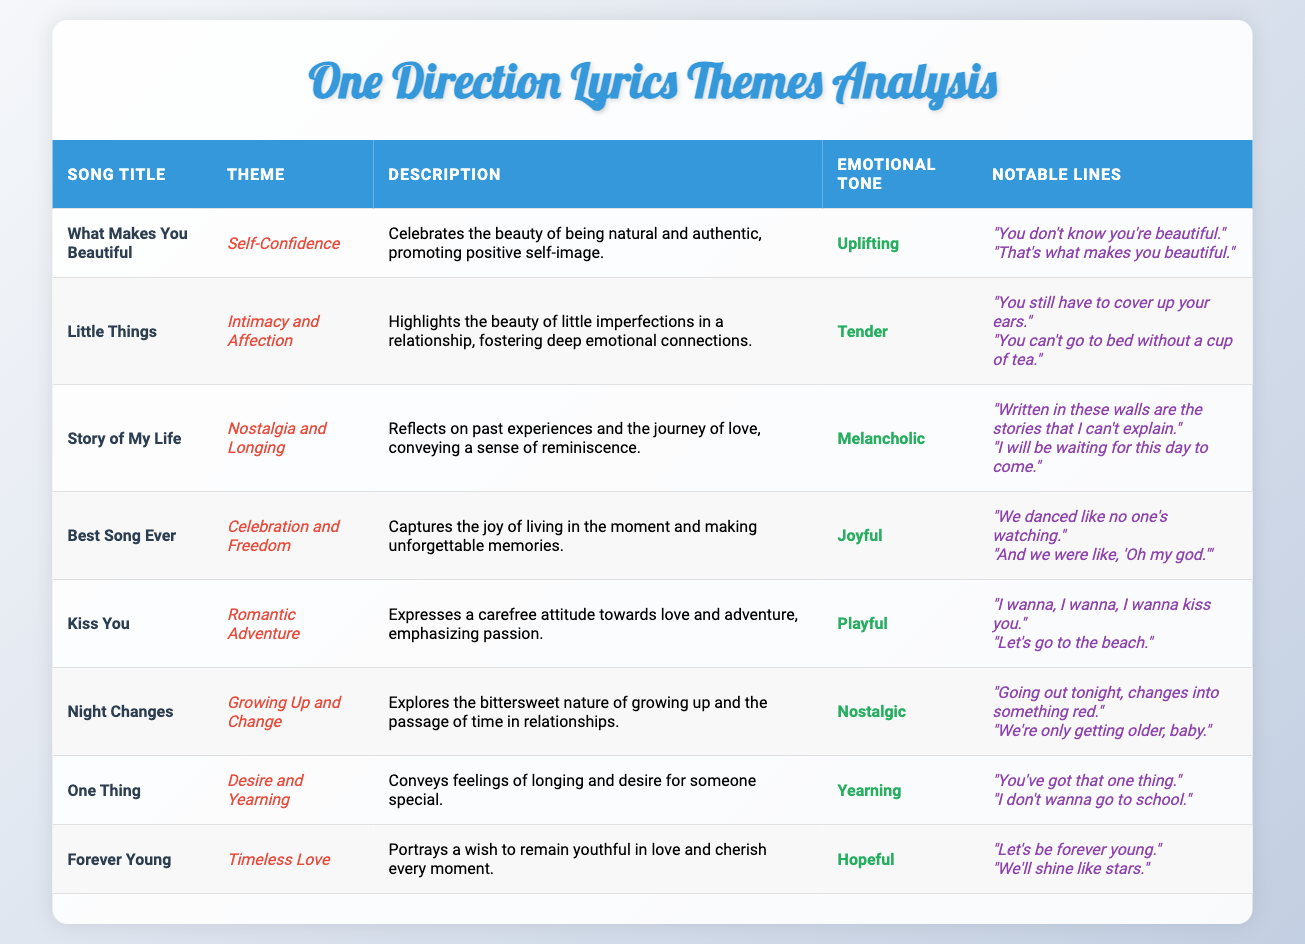What theme is associated with the song "Kiss You"? The song "Kiss You" has the theme of "Romantic Adventure." This is directly stated in the table under the "Theme" column for the respective song title.
Answer: Romantic Adventure Which song has a melancholic emotional tone? "Story of My Life" is listed in the table with a melancholic emotional tone in the corresponding column.
Answer: Story of My Life Are there any songs that focus on self-confidence? Yes, "What Makes You Beautiful" is clearly labeled in the theme column as focusing on self-confidence.
Answer: Yes What are the notable lines from the song "Night Changes"? The notable lines for "Night Changes," as shown in the table, are "Going out tonight, changes into something red." and "We're only getting older, baby." These lines can be found in the notable lines column for that specific song.
Answer: "Going out tonight, changes into something red." and "We're only getting older, baby." What is the average emotional tone of the songs listed? The emotional tones of the songs are categorized as follows: Uplifting, Tender, Melancholic, Joyful, Playful, Nostalgic, Yearning, and Hopeful. Since there are no numerical values assigned to these tones, an average cannot be calculated directly. Thus, the answer is that an average emotional tone cannot be determined from this qualitative data.
Answer: Average emotional tone cannot be calculated Which two songs have themes related to nostalgia? The two songs linked to the theme of nostalgia are "Story of My Life" and "Night Changes." By reviewing the table, both songs are categorized under nostalgia-related themes in their respective rows.
Answer: Story of My Life and Night Changes What is the relationship between the themes of "Little Things" and "One Thing"? "Little Things" has a theme of intimacy and affection, while "One Thing" relates to desire and yearning. Analyzing the themes from the table, the relationship highlights different aspects of romantic connections—intimacy and affection in one, and yearning and desire in the other.
Answer: Different aspects of romantic connections How many songs feature a hopeful emotional tone? There is one song with a hopeful emotional tone, which is "Forever Young." The emotional tone for this song in the table is clearly marked as hopeful.
Answer: 1 